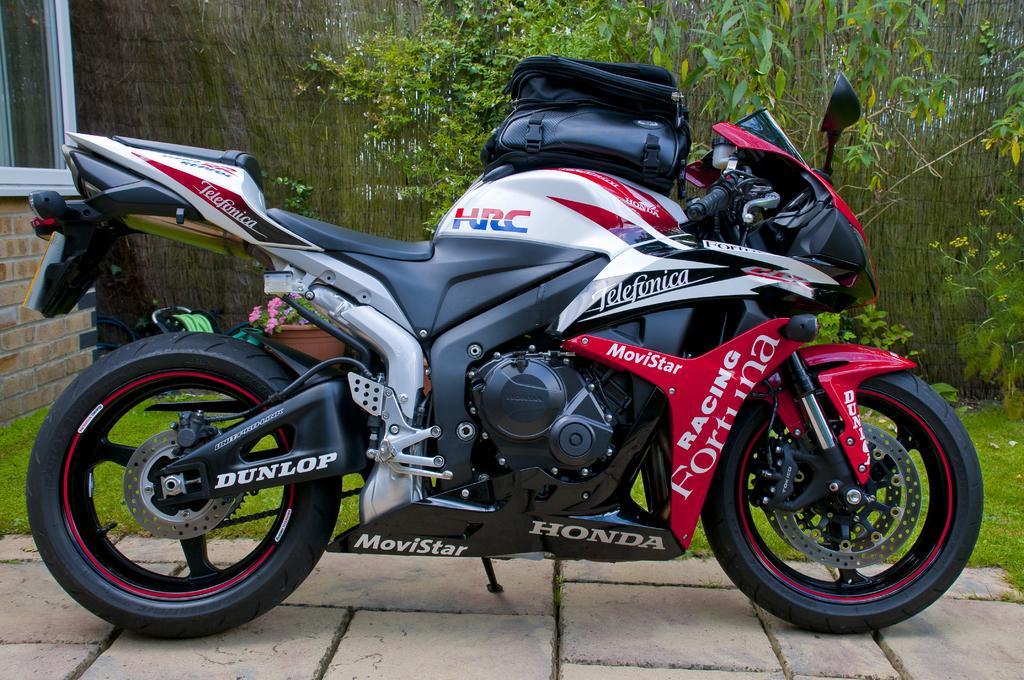How would you summarize this image in a sentence or two? In the center of the image, we can see a bag on the bike and in the background, there are trees and a building and we can see a flower pot and some plants. 